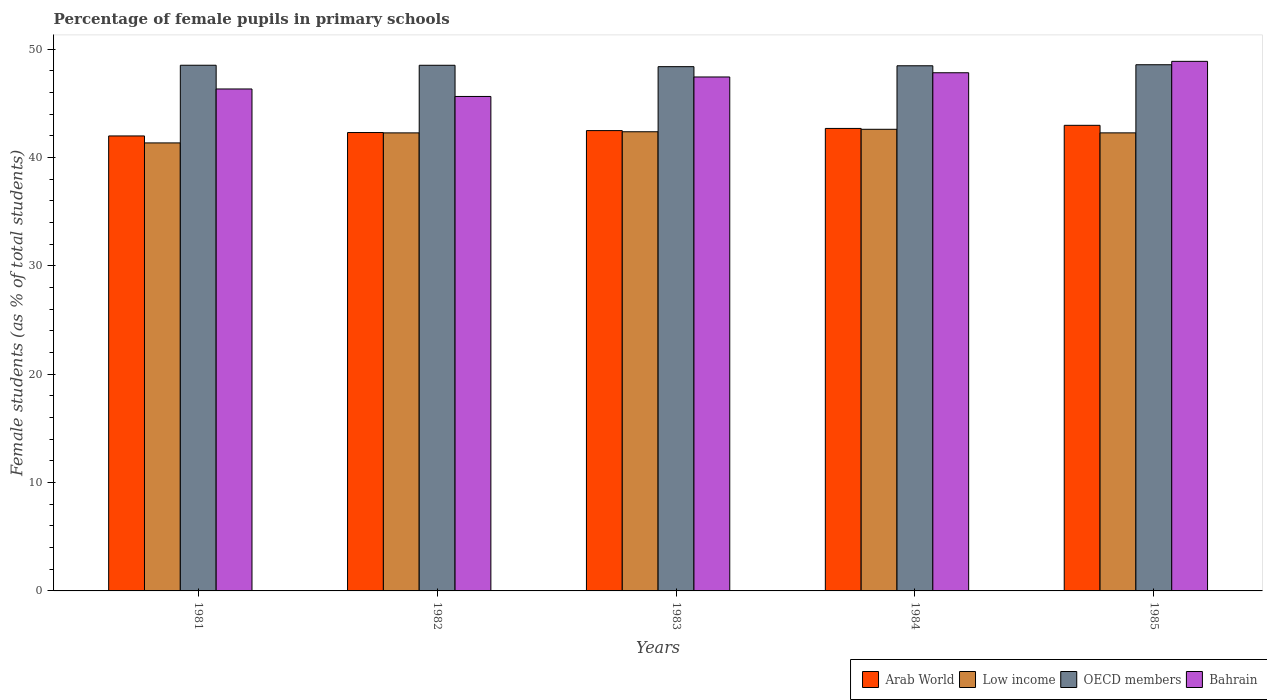Are the number of bars per tick equal to the number of legend labels?
Your answer should be very brief. Yes. What is the percentage of female pupils in primary schools in OECD members in 1982?
Provide a short and direct response. 48.5. Across all years, what is the maximum percentage of female pupils in primary schools in Bahrain?
Ensure brevity in your answer.  48.86. Across all years, what is the minimum percentage of female pupils in primary schools in Arab World?
Give a very brief answer. 41.98. In which year was the percentage of female pupils in primary schools in Low income maximum?
Keep it short and to the point. 1984. What is the total percentage of female pupils in primary schools in Bahrain in the graph?
Provide a succinct answer. 236.03. What is the difference between the percentage of female pupils in primary schools in Low income in 1982 and that in 1985?
Your answer should be compact. -0. What is the difference between the percentage of female pupils in primary schools in Low income in 1981 and the percentage of female pupils in primary schools in Bahrain in 1982?
Offer a terse response. -4.29. What is the average percentage of female pupils in primary schools in Low income per year?
Provide a short and direct response. 42.16. In the year 1981, what is the difference between the percentage of female pupils in primary schools in Bahrain and percentage of female pupils in primary schools in Arab World?
Your answer should be compact. 4.33. In how many years, is the percentage of female pupils in primary schools in Bahrain greater than 28 %?
Your answer should be very brief. 5. What is the ratio of the percentage of female pupils in primary schools in Arab World in 1982 to that in 1985?
Offer a very short reply. 0.98. What is the difference between the highest and the second highest percentage of female pupils in primary schools in Arab World?
Your response must be concise. 0.29. What is the difference between the highest and the lowest percentage of female pupils in primary schools in Arab World?
Your answer should be compact. 0.98. Is the sum of the percentage of female pupils in primary schools in Low income in 1981 and 1985 greater than the maximum percentage of female pupils in primary schools in Bahrain across all years?
Provide a succinct answer. Yes. What does the 3rd bar from the left in 1984 represents?
Provide a succinct answer. OECD members. Is it the case that in every year, the sum of the percentage of female pupils in primary schools in OECD members and percentage of female pupils in primary schools in Arab World is greater than the percentage of female pupils in primary schools in Low income?
Keep it short and to the point. Yes. How many bars are there?
Your answer should be very brief. 20. How many years are there in the graph?
Your answer should be compact. 5. What is the difference between two consecutive major ticks on the Y-axis?
Make the answer very short. 10. Where does the legend appear in the graph?
Give a very brief answer. Bottom right. How many legend labels are there?
Your answer should be very brief. 4. What is the title of the graph?
Offer a terse response. Percentage of female pupils in primary schools. Does "Latin America(developing only)" appear as one of the legend labels in the graph?
Keep it short and to the point. No. What is the label or title of the Y-axis?
Give a very brief answer. Female students (as % of total students). What is the Female students (as % of total students) in Arab World in 1981?
Ensure brevity in your answer.  41.98. What is the Female students (as % of total students) of Low income in 1981?
Keep it short and to the point. 41.34. What is the Female students (as % of total students) of OECD members in 1981?
Your answer should be very brief. 48.5. What is the Female students (as % of total students) in Bahrain in 1981?
Offer a terse response. 46.31. What is the Female students (as % of total students) in Arab World in 1982?
Your answer should be very brief. 42.29. What is the Female students (as % of total students) in Low income in 1982?
Provide a short and direct response. 42.26. What is the Female students (as % of total students) of OECD members in 1982?
Your answer should be very brief. 48.5. What is the Female students (as % of total students) in Bahrain in 1982?
Keep it short and to the point. 45.62. What is the Female students (as % of total students) in Arab World in 1983?
Give a very brief answer. 42.47. What is the Female students (as % of total students) in Low income in 1983?
Offer a very short reply. 42.37. What is the Female students (as % of total students) in OECD members in 1983?
Provide a succinct answer. 48.37. What is the Female students (as % of total students) in Bahrain in 1983?
Offer a terse response. 47.42. What is the Female students (as % of total students) of Arab World in 1984?
Give a very brief answer. 42.67. What is the Female students (as % of total students) of Low income in 1984?
Your answer should be very brief. 42.59. What is the Female students (as % of total students) of OECD members in 1984?
Your answer should be very brief. 48.45. What is the Female students (as % of total students) of Bahrain in 1984?
Ensure brevity in your answer.  47.81. What is the Female students (as % of total students) of Arab World in 1985?
Your response must be concise. 42.96. What is the Female students (as % of total students) of Low income in 1985?
Provide a short and direct response. 42.26. What is the Female students (as % of total students) of OECD members in 1985?
Ensure brevity in your answer.  48.55. What is the Female students (as % of total students) of Bahrain in 1985?
Your answer should be very brief. 48.86. Across all years, what is the maximum Female students (as % of total students) of Arab World?
Your answer should be compact. 42.96. Across all years, what is the maximum Female students (as % of total students) in Low income?
Make the answer very short. 42.59. Across all years, what is the maximum Female students (as % of total students) of OECD members?
Offer a very short reply. 48.55. Across all years, what is the maximum Female students (as % of total students) in Bahrain?
Make the answer very short. 48.86. Across all years, what is the minimum Female students (as % of total students) in Arab World?
Give a very brief answer. 41.98. Across all years, what is the minimum Female students (as % of total students) in Low income?
Give a very brief answer. 41.34. Across all years, what is the minimum Female students (as % of total students) of OECD members?
Keep it short and to the point. 48.37. Across all years, what is the minimum Female students (as % of total students) in Bahrain?
Ensure brevity in your answer.  45.62. What is the total Female students (as % of total students) of Arab World in the graph?
Provide a succinct answer. 212.37. What is the total Female students (as % of total students) in Low income in the graph?
Offer a terse response. 210.82. What is the total Female students (as % of total students) in OECD members in the graph?
Provide a short and direct response. 242.38. What is the total Female students (as % of total students) of Bahrain in the graph?
Offer a terse response. 236.03. What is the difference between the Female students (as % of total students) of Arab World in 1981 and that in 1982?
Offer a terse response. -0.31. What is the difference between the Female students (as % of total students) of Low income in 1981 and that in 1982?
Keep it short and to the point. -0.93. What is the difference between the Female students (as % of total students) of OECD members in 1981 and that in 1982?
Your answer should be very brief. 0. What is the difference between the Female students (as % of total students) in Bahrain in 1981 and that in 1982?
Offer a terse response. 0.69. What is the difference between the Female students (as % of total students) of Arab World in 1981 and that in 1983?
Your answer should be very brief. -0.49. What is the difference between the Female students (as % of total students) in Low income in 1981 and that in 1983?
Your response must be concise. -1.03. What is the difference between the Female students (as % of total students) of OECD members in 1981 and that in 1983?
Your answer should be very brief. 0.13. What is the difference between the Female students (as % of total students) in Bahrain in 1981 and that in 1983?
Keep it short and to the point. -1.11. What is the difference between the Female students (as % of total students) in Arab World in 1981 and that in 1984?
Keep it short and to the point. -0.69. What is the difference between the Female students (as % of total students) of Low income in 1981 and that in 1984?
Your answer should be very brief. -1.26. What is the difference between the Female students (as % of total students) in OECD members in 1981 and that in 1984?
Your response must be concise. 0.05. What is the difference between the Female students (as % of total students) in Bahrain in 1981 and that in 1984?
Your answer should be compact. -1.5. What is the difference between the Female students (as % of total students) of Arab World in 1981 and that in 1985?
Provide a succinct answer. -0.98. What is the difference between the Female students (as % of total students) in Low income in 1981 and that in 1985?
Ensure brevity in your answer.  -0.93. What is the difference between the Female students (as % of total students) of OECD members in 1981 and that in 1985?
Your answer should be compact. -0.05. What is the difference between the Female students (as % of total students) in Bahrain in 1981 and that in 1985?
Your response must be concise. -2.55. What is the difference between the Female students (as % of total students) of Arab World in 1982 and that in 1983?
Offer a very short reply. -0.18. What is the difference between the Female students (as % of total students) of Low income in 1982 and that in 1983?
Provide a short and direct response. -0.1. What is the difference between the Female students (as % of total students) of OECD members in 1982 and that in 1983?
Keep it short and to the point. 0.13. What is the difference between the Female students (as % of total students) of Bahrain in 1982 and that in 1983?
Give a very brief answer. -1.8. What is the difference between the Female students (as % of total students) in Arab World in 1982 and that in 1984?
Offer a terse response. -0.38. What is the difference between the Female students (as % of total students) in Low income in 1982 and that in 1984?
Offer a very short reply. -0.33. What is the difference between the Female students (as % of total students) in OECD members in 1982 and that in 1984?
Your answer should be very brief. 0.05. What is the difference between the Female students (as % of total students) of Bahrain in 1982 and that in 1984?
Keep it short and to the point. -2.19. What is the difference between the Female students (as % of total students) of Arab World in 1982 and that in 1985?
Provide a succinct answer. -0.67. What is the difference between the Female students (as % of total students) of Low income in 1982 and that in 1985?
Ensure brevity in your answer.  -0. What is the difference between the Female students (as % of total students) of OECD members in 1982 and that in 1985?
Offer a very short reply. -0.05. What is the difference between the Female students (as % of total students) of Bahrain in 1982 and that in 1985?
Make the answer very short. -3.24. What is the difference between the Female students (as % of total students) in Arab World in 1983 and that in 1984?
Your response must be concise. -0.2. What is the difference between the Female students (as % of total students) in Low income in 1983 and that in 1984?
Provide a short and direct response. -0.23. What is the difference between the Female students (as % of total students) of OECD members in 1983 and that in 1984?
Your answer should be very brief. -0.08. What is the difference between the Female students (as % of total students) in Bahrain in 1983 and that in 1984?
Your response must be concise. -0.39. What is the difference between the Female students (as % of total students) in Arab World in 1983 and that in 1985?
Ensure brevity in your answer.  -0.49. What is the difference between the Female students (as % of total students) of Low income in 1983 and that in 1985?
Your response must be concise. 0.1. What is the difference between the Female students (as % of total students) in OECD members in 1983 and that in 1985?
Your response must be concise. -0.18. What is the difference between the Female students (as % of total students) of Bahrain in 1983 and that in 1985?
Make the answer very short. -1.44. What is the difference between the Female students (as % of total students) in Arab World in 1984 and that in 1985?
Your answer should be very brief. -0.29. What is the difference between the Female students (as % of total students) of Low income in 1984 and that in 1985?
Your response must be concise. 0.33. What is the difference between the Female students (as % of total students) of OECD members in 1984 and that in 1985?
Offer a terse response. -0.1. What is the difference between the Female students (as % of total students) in Bahrain in 1984 and that in 1985?
Offer a very short reply. -1.05. What is the difference between the Female students (as % of total students) of Arab World in 1981 and the Female students (as % of total students) of Low income in 1982?
Your answer should be very brief. -0.28. What is the difference between the Female students (as % of total students) in Arab World in 1981 and the Female students (as % of total students) in OECD members in 1982?
Provide a short and direct response. -6.52. What is the difference between the Female students (as % of total students) in Arab World in 1981 and the Female students (as % of total students) in Bahrain in 1982?
Give a very brief answer. -3.64. What is the difference between the Female students (as % of total students) in Low income in 1981 and the Female students (as % of total students) in OECD members in 1982?
Give a very brief answer. -7.16. What is the difference between the Female students (as % of total students) in Low income in 1981 and the Female students (as % of total students) in Bahrain in 1982?
Provide a short and direct response. -4.29. What is the difference between the Female students (as % of total students) in OECD members in 1981 and the Female students (as % of total students) in Bahrain in 1982?
Your response must be concise. 2.88. What is the difference between the Female students (as % of total students) in Arab World in 1981 and the Female students (as % of total students) in Low income in 1983?
Keep it short and to the point. -0.39. What is the difference between the Female students (as % of total students) in Arab World in 1981 and the Female students (as % of total students) in OECD members in 1983?
Ensure brevity in your answer.  -6.39. What is the difference between the Female students (as % of total students) of Arab World in 1981 and the Female students (as % of total students) of Bahrain in 1983?
Offer a terse response. -5.44. What is the difference between the Female students (as % of total students) in Low income in 1981 and the Female students (as % of total students) in OECD members in 1983?
Your response must be concise. -7.04. What is the difference between the Female students (as % of total students) in Low income in 1981 and the Female students (as % of total students) in Bahrain in 1983?
Provide a succinct answer. -6.08. What is the difference between the Female students (as % of total students) of OECD members in 1981 and the Female students (as % of total students) of Bahrain in 1983?
Provide a succinct answer. 1.08. What is the difference between the Female students (as % of total students) in Arab World in 1981 and the Female students (as % of total students) in Low income in 1984?
Provide a short and direct response. -0.61. What is the difference between the Female students (as % of total students) of Arab World in 1981 and the Female students (as % of total students) of OECD members in 1984?
Your answer should be very brief. -6.47. What is the difference between the Female students (as % of total students) in Arab World in 1981 and the Female students (as % of total students) in Bahrain in 1984?
Your answer should be compact. -5.83. What is the difference between the Female students (as % of total students) in Low income in 1981 and the Female students (as % of total students) in OECD members in 1984?
Offer a terse response. -7.12. What is the difference between the Female students (as % of total students) in Low income in 1981 and the Female students (as % of total students) in Bahrain in 1984?
Ensure brevity in your answer.  -6.47. What is the difference between the Female students (as % of total students) of OECD members in 1981 and the Female students (as % of total students) of Bahrain in 1984?
Make the answer very short. 0.69. What is the difference between the Female students (as % of total students) of Arab World in 1981 and the Female students (as % of total students) of Low income in 1985?
Ensure brevity in your answer.  -0.28. What is the difference between the Female students (as % of total students) in Arab World in 1981 and the Female students (as % of total students) in OECD members in 1985?
Offer a terse response. -6.57. What is the difference between the Female students (as % of total students) in Arab World in 1981 and the Female students (as % of total students) in Bahrain in 1985?
Keep it short and to the point. -6.88. What is the difference between the Female students (as % of total students) of Low income in 1981 and the Female students (as % of total students) of OECD members in 1985?
Your response must be concise. -7.21. What is the difference between the Female students (as % of total students) of Low income in 1981 and the Female students (as % of total students) of Bahrain in 1985?
Ensure brevity in your answer.  -7.53. What is the difference between the Female students (as % of total students) in OECD members in 1981 and the Female students (as % of total students) in Bahrain in 1985?
Provide a succinct answer. -0.36. What is the difference between the Female students (as % of total students) in Arab World in 1982 and the Female students (as % of total students) in Low income in 1983?
Your answer should be very brief. -0.07. What is the difference between the Female students (as % of total students) in Arab World in 1982 and the Female students (as % of total students) in OECD members in 1983?
Your answer should be compact. -6.08. What is the difference between the Female students (as % of total students) in Arab World in 1982 and the Female students (as % of total students) in Bahrain in 1983?
Keep it short and to the point. -5.13. What is the difference between the Female students (as % of total students) in Low income in 1982 and the Female students (as % of total students) in OECD members in 1983?
Your answer should be compact. -6.11. What is the difference between the Female students (as % of total students) of Low income in 1982 and the Female students (as % of total students) of Bahrain in 1983?
Your answer should be compact. -5.16. What is the difference between the Female students (as % of total students) of OECD members in 1982 and the Female students (as % of total students) of Bahrain in 1983?
Your answer should be very brief. 1.08. What is the difference between the Female students (as % of total students) in Arab World in 1982 and the Female students (as % of total students) in Low income in 1984?
Offer a terse response. -0.3. What is the difference between the Female students (as % of total students) in Arab World in 1982 and the Female students (as % of total students) in OECD members in 1984?
Your response must be concise. -6.16. What is the difference between the Female students (as % of total students) in Arab World in 1982 and the Female students (as % of total students) in Bahrain in 1984?
Offer a terse response. -5.52. What is the difference between the Female students (as % of total students) in Low income in 1982 and the Female students (as % of total students) in OECD members in 1984?
Your answer should be compact. -6.19. What is the difference between the Female students (as % of total students) of Low income in 1982 and the Female students (as % of total students) of Bahrain in 1984?
Keep it short and to the point. -5.55. What is the difference between the Female students (as % of total students) of OECD members in 1982 and the Female students (as % of total students) of Bahrain in 1984?
Your answer should be compact. 0.69. What is the difference between the Female students (as % of total students) in Arab World in 1982 and the Female students (as % of total students) in Low income in 1985?
Your answer should be very brief. 0.03. What is the difference between the Female students (as % of total students) in Arab World in 1982 and the Female students (as % of total students) in OECD members in 1985?
Offer a terse response. -6.26. What is the difference between the Female students (as % of total students) of Arab World in 1982 and the Female students (as % of total students) of Bahrain in 1985?
Make the answer very short. -6.57. What is the difference between the Female students (as % of total students) in Low income in 1982 and the Female students (as % of total students) in OECD members in 1985?
Offer a very short reply. -6.29. What is the difference between the Female students (as % of total students) of Low income in 1982 and the Female students (as % of total students) of Bahrain in 1985?
Offer a terse response. -6.6. What is the difference between the Female students (as % of total students) of OECD members in 1982 and the Female students (as % of total students) of Bahrain in 1985?
Your answer should be compact. -0.36. What is the difference between the Female students (as % of total students) in Arab World in 1983 and the Female students (as % of total students) in Low income in 1984?
Ensure brevity in your answer.  -0.12. What is the difference between the Female students (as % of total students) in Arab World in 1983 and the Female students (as % of total students) in OECD members in 1984?
Ensure brevity in your answer.  -5.98. What is the difference between the Female students (as % of total students) of Arab World in 1983 and the Female students (as % of total students) of Bahrain in 1984?
Provide a succinct answer. -5.34. What is the difference between the Female students (as % of total students) of Low income in 1983 and the Female students (as % of total students) of OECD members in 1984?
Ensure brevity in your answer.  -6.09. What is the difference between the Female students (as % of total students) of Low income in 1983 and the Female students (as % of total students) of Bahrain in 1984?
Ensure brevity in your answer.  -5.44. What is the difference between the Female students (as % of total students) in OECD members in 1983 and the Female students (as % of total students) in Bahrain in 1984?
Provide a short and direct response. 0.56. What is the difference between the Female students (as % of total students) of Arab World in 1983 and the Female students (as % of total students) of Low income in 1985?
Your response must be concise. 0.21. What is the difference between the Female students (as % of total students) in Arab World in 1983 and the Female students (as % of total students) in OECD members in 1985?
Give a very brief answer. -6.08. What is the difference between the Female students (as % of total students) of Arab World in 1983 and the Female students (as % of total students) of Bahrain in 1985?
Provide a succinct answer. -6.39. What is the difference between the Female students (as % of total students) in Low income in 1983 and the Female students (as % of total students) in OECD members in 1985?
Give a very brief answer. -6.18. What is the difference between the Female students (as % of total students) of Low income in 1983 and the Female students (as % of total students) of Bahrain in 1985?
Keep it short and to the point. -6.5. What is the difference between the Female students (as % of total students) in OECD members in 1983 and the Female students (as % of total students) in Bahrain in 1985?
Keep it short and to the point. -0.49. What is the difference between the Female students (as % of total students) in Arab World in 1984 and the Female students (as % of total students) in Low income in 1985?
Provide a short and direct response. 0.41. What is the difference between the Female students (as % of total students) of Arab World in 1984 and the Female students (as % of total students) of OECD members in 1985?
Offer a terse response. -5.88. What is the difference between the Female students (as % of total students) in Arab World in 1984 and the Female students (as % of total students) in Bahrain in 1985?
Your answer should be compact. -6.19. What is the difference between the Female students (as % of total students) in Low income in 1984 and the Female students (as % of total students) in OECD members in 1985?
Your answer should be compact. -5.96. What is the difference between the Female students (as % of total students) in Low income in 1984 and the Female students (as % of total students) in Bahrain in 1985?
Provide a succinct answer. -6.27. What is the difference between the Female students (as % of total students) in OECD members in 1984 and the Female students (as % of total students) in Bahrain in 1985?
Offer a very short reply. -0.41. What is the average Female students (as % of total students) in Arab World per year?
Provide a succinct answer. 42.47. What is the average Female students (as % of total students) of Low income per year?
Your response must be concise. 42.16. What is the average Female students (as % of total students) in OECD members per year?
Ensure brevity in your answer.  48.48. What is the average Female students (as % of total students) of Bahrain per year?
Provide a short and direct response. 47.21. In the year 1981, what is the difference between the Female students (as % of total students) in Arab World and Female students (as % of total students) in Low income?
Provide a succinct answer. 0.64. In the year 1981, what is the difference between the Female students (as % of total students) of Arab World and Female students (as % of total students) of OECD members?
Make the answer very short. -6.52. In the year 1981, what is the difference between the Female students (as % of total students) in Arab World and Female students (as % of total students) in Bahrain?
Provide a succinct answer. -4.33. In the year 1981, what is the difference between the Female students (as % of total students) in Low income and Female students (as % of total students) in OECD members?
Your answer should be compact. -7.17. In the year 1981, what is the difference between the Female students (as % of total students) in Low income and Female students (as % of total students) in Bahrain?
Keep it short and to the point. -4.98. In the year 1981, what is the difference between the Female students (as % of total students) of OECD members and Female students (as % of total students) of Bahrain?
Make the answer very short. 2.19. In the year 1982, what is the difference between the Female students (as % of total students) of Arab World and Female students (as % of total students) of Low income?
Keep it short and to the point. 0.03. In the year 1982, what is the difference between the Female students (as % of total students) of Arab World and Female students (as % of total students) of OECD members?
Your answer should be very brief. -6.21. In the year 1982, what is the difference between the Female students (as % of total students) of Arab World and Female students (as % of total students) of Bahrain?
Keep it short and to the point. -3.33. In the year 1982, what is the difference between the Female students (as % of total students) of Low income and Female students (as % of total students) of OECD members?
Keep it short and to the point. -6.24. In the year 1982, what is the difference between the Female students (as % of total students) in Low income and Female students (as % of total students) in Bahrain?
Offer a terse response. -3.36. In the year 1982, what is the difference between the Female students (as % of total students) in OECD members and Female students (as % of total students) in Bahrain?
Keep it short and to the point. 2.88. In the year 1983, what is the difference between the Female students (as % of total students) of Arab World and Female students (as % of total students) of Low income?
Your response must be concise. 0.11. In the year 1983, what is the difference between the Female students (as % of total students) in Arab World and Female students (as % of total students) in OECD members?
Keep it short and to the point. -5.9. In the year 1983, what is the difference between the Female students (as % of total students) in Arab World and Female students (as % of total students) in Bahrain?
Give a very brief answer. -4.95. In the year 1983, what is the difference between the Female students (as % of total students) in Low income and Female students (as % of total students) in OECD members?
Give a very brief answer. -6.01. In the year 1983, what is the difference between the Female students (as % of total students) in Low income and Female students (as % of total students) in Bahrain?
Your answer should be compact. -5.06. In the year 1983, what is the difference between the Female students (as % of total students) in OECD members and Female students (as % of total students) in Bahrain?
Offer a terse response. 0.95. In the year 1984, what is the difference between the Female students (as % of total students) of Arab World and Female students (as % of total students) of Low income?
Ensure brevity in your answer.  0.08. In the year 1984, what is the difference between the Female students (as % of total students) of Arab World and Female students (as % of total students) of OECD members?
Provide a succinct answer. -5.78. In the year 1984, what is the difference between the Female students (as % of total students) of Arab World and Female students (as % of total students) of Bahrain?
Give a very brief answer. -5.14. In the year 1984, what is the difference between the Female students (as % of total students) in Low income and Female students (as % of total students) in OECD members?
Offer a very short reply. -5.86. In the year 1984, what is the difference between the Female students (as % of total students) in Low income and Female students (as % of total students) in Bahrain?
Provide a succinct answer. -5.22. In the year 1984, what is the difference between the Female students (as % of total students) in OECD members and Female students (as % of total students) in Bahrain?
Your answer should be very brief. 0.64. In the year 1985, what is the difference between the Female students (as % of total students) in Arab World and Female students (as % of total students) in Low income?
Your answer should be compact. 0.7. In the year 1985, what is the difference between the Female students (as % of total students) of Arab World and Female students (as % of total students) of OECD members?
Provide a succinct answer. -5.59. In the year 1985, what is the difference between the Female students (as % of total students) in Arab World and Female students (as % of total students) in Bahrain?
Your answer should be compact. -5.9. In the year 1985, what is the difference between the Female students (as % of total students) of Low income and Female students (as % of total students) of OECD members?
Give a very brief answer. -6.29. In the year 1985, what is the difference between the Female students (as % of total students) in Low income and Female students (as % of total students) in Bahrain?
Offer a very short reply. -6.6. In the year 1985, what is the difference between the Female students (as % of total students) of OECD members and Female students (as % of total students) of Bahrain?
Ensure brevity in your answer.  -0.31. What is the ratio of the Female students (as % of total students) in Low income in 1981 to that in 1982?
Provide a succinct answer. 0.98. What is the ratio of the Female students (as % of total students) of Bahrain in 1981 to that in 1982?
Give a very brief answer. 1.02. What is the ratio of the Female students (as % of total students) of Arab World in 1981 to that in 1983?
Provide a succinct answer. 0.99. What is the ratio of the Female students (as % of total students) of Low income in 1981 to that in 1983?
Ensure brevity in your answer.  0.98. What is the ratio of the Female students (as % of total students) of OECD members in 1981 to that in 1983?
Offer a terse response. 1. What is the ratio of the Female students (as % of total students) in Bahrain in 1981 to that in 1983?
Your answer should be very brief. 0.98. What is the ratio of the Female students (as % of total students) in Arab World in 1981 to that in 1984?
Your answer should be compact. 0.98. What is the ratio of the Female students (as % of total students) of Low income in 1981 to that in 1984?
Your answer should be very brief. 0.97. What is the ratio of the Female students (as % of total students) in Bahrain in 1981 to that in 1984?
Keep it short and to the point. 0.97. What is the ratio of the Female students (as % of total students) in Arab World in 1981 to that in 1985?
Provide a short and direct response. 0.98. What is the ratio of the Female students (as % of total students) of Low income in 1981 to that in 1985?
Offer a terse response. 0.98. What is the ratio of the Female students (as % of total students) in Bahrain in 1981 to that in 1985?
Your answer should be very brief. 0.95. What is the ratio of the Female students (as % of total students) in Arab World in 1982 to that in 1983?
Your answer should be very brief. 1. What is the ratio of the Female students (as % of total students) in Bahrain in 1982 to that in 1983?
Make the answer very short. 0.96. What is the ratio of the Female students (as % of total students) in Low income in 1982 to that in 1984?
Offer a terse response. 0.99. What is the ratio of the Female students (as % of total students) in Bahrain in 1982 to that in 1984?
Ensure brevity in your answer.  0.95. What is the ratio of the Female students (as % of total students) in Arab World in 1982 to that in 1985?
Give a very brief answer. 0.98. What is the ratio of the Female students (as % of total students) of Bahrain in 1982 to that in 1985?
Offer a terse response. 0.93. What is the ratio of the Female students (as % of total students) of Arab World in 1983 to that in 1984?
Your response must be concise. 1. What is the ratio of the Female students (as % of total students) of OECD members in 1983 to that in 1984?
Offer a very short reply. 1. What is the ratio of the Female students (as % of total students) in Arab World in 1983 to that in 1985?
Your answer should be compact. 0.99. What is the ratio of the Female students (as % of total students) of Bahrain in 1983 to that in 1985?
Provide a succinct answer. 0.97. What is the ratio of the Female students (as % of total students) of Low income in 1984 to that in 1985?
Your answer should be compact. 1.01. What is the ratio of the Female students (as % of total students) of OECD members in 1984 to that in 1985?
Your response must be concise. 1. What is the ratio of the Female students (as % of total students) of Bahrain in 1984 to that in 1985?
Offer a very short reply. 0.98. What is the difference between the highest and the second highest Female students (as % of total students) in Arab World?
Offer a terse response. 0.29. What is the difference between the highest and the second highest Female students (as % of total students) of Low income?
Provide a short and direct response. 0.23. What is the difference between the highest and the second highest Female students (as % of total students) in OECD members?
Make the answer very short. 0.05. What is the difference between the highest and the second highest Female students (as % of total students) of Bahrain?
Your response must be concise. 1.05. What is the difference between the highest and the lowest Female students (as % of total students) of Low income?
Your response must be concise. 1.26. What is the difference between the highest and the lowest Female students (as % of total students) of OECD members?
Provide a short and direct response. 0.18. What is the difference between the highest and the lowest Female students (as % of total students) of Bahrain?
Provide a short and direct response. 3.24. 